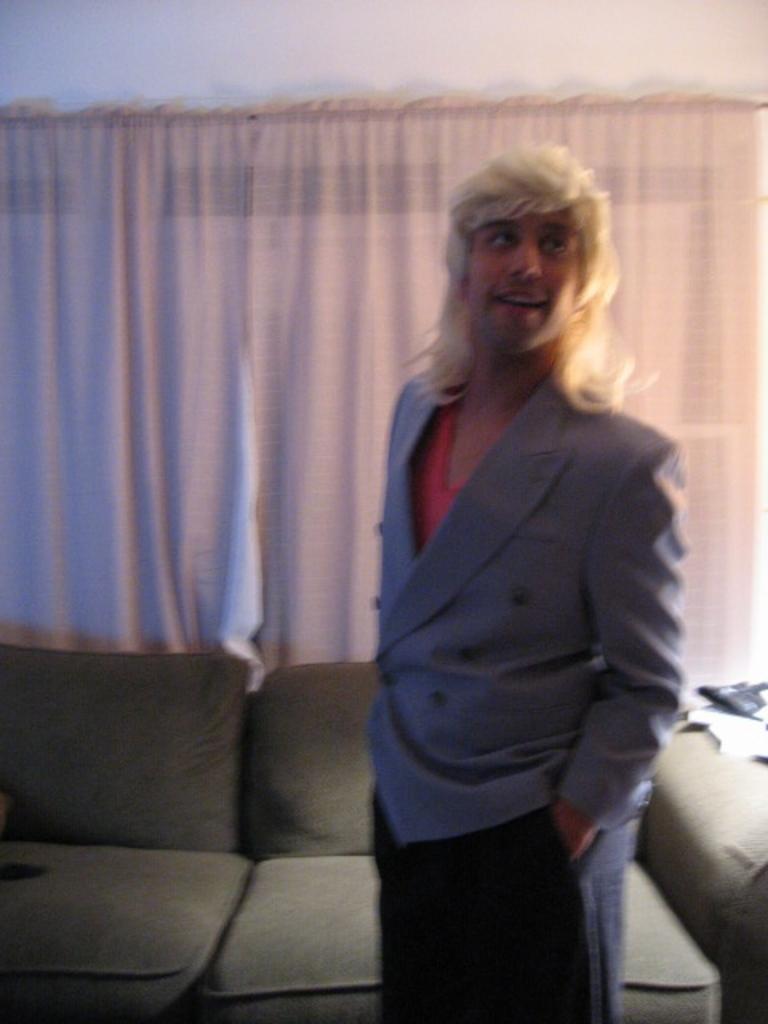In one or two sentences, can you explain what this image depicts? This is the picture of a person in a grey blazer standing on the floor. Behind the person there are sofas, curtains and a white wall. 